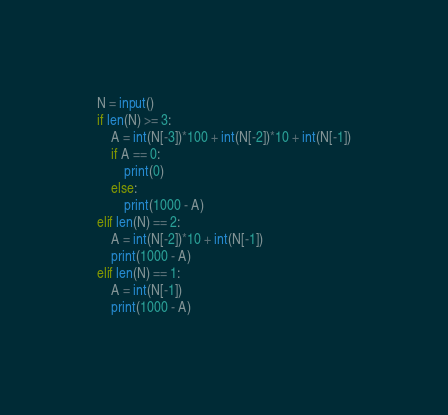<code> <loc_0><loc_0><loc_500><loc_500><_Python_>N = input()
if len(N) >= 3:
    A = int(N[-3])*100 + int(N[-2])*10 + int(N[-1])
    if A == 0:
        print(0)
    else:
        print(1000 - A)
elif len(N) == 2:
    A = int(N[-2])*10 + int(N[-1])
    print(1000 - A)
elif len(N) == 1:
    A = int(N[-1])
    print(1000 - A)</code> 